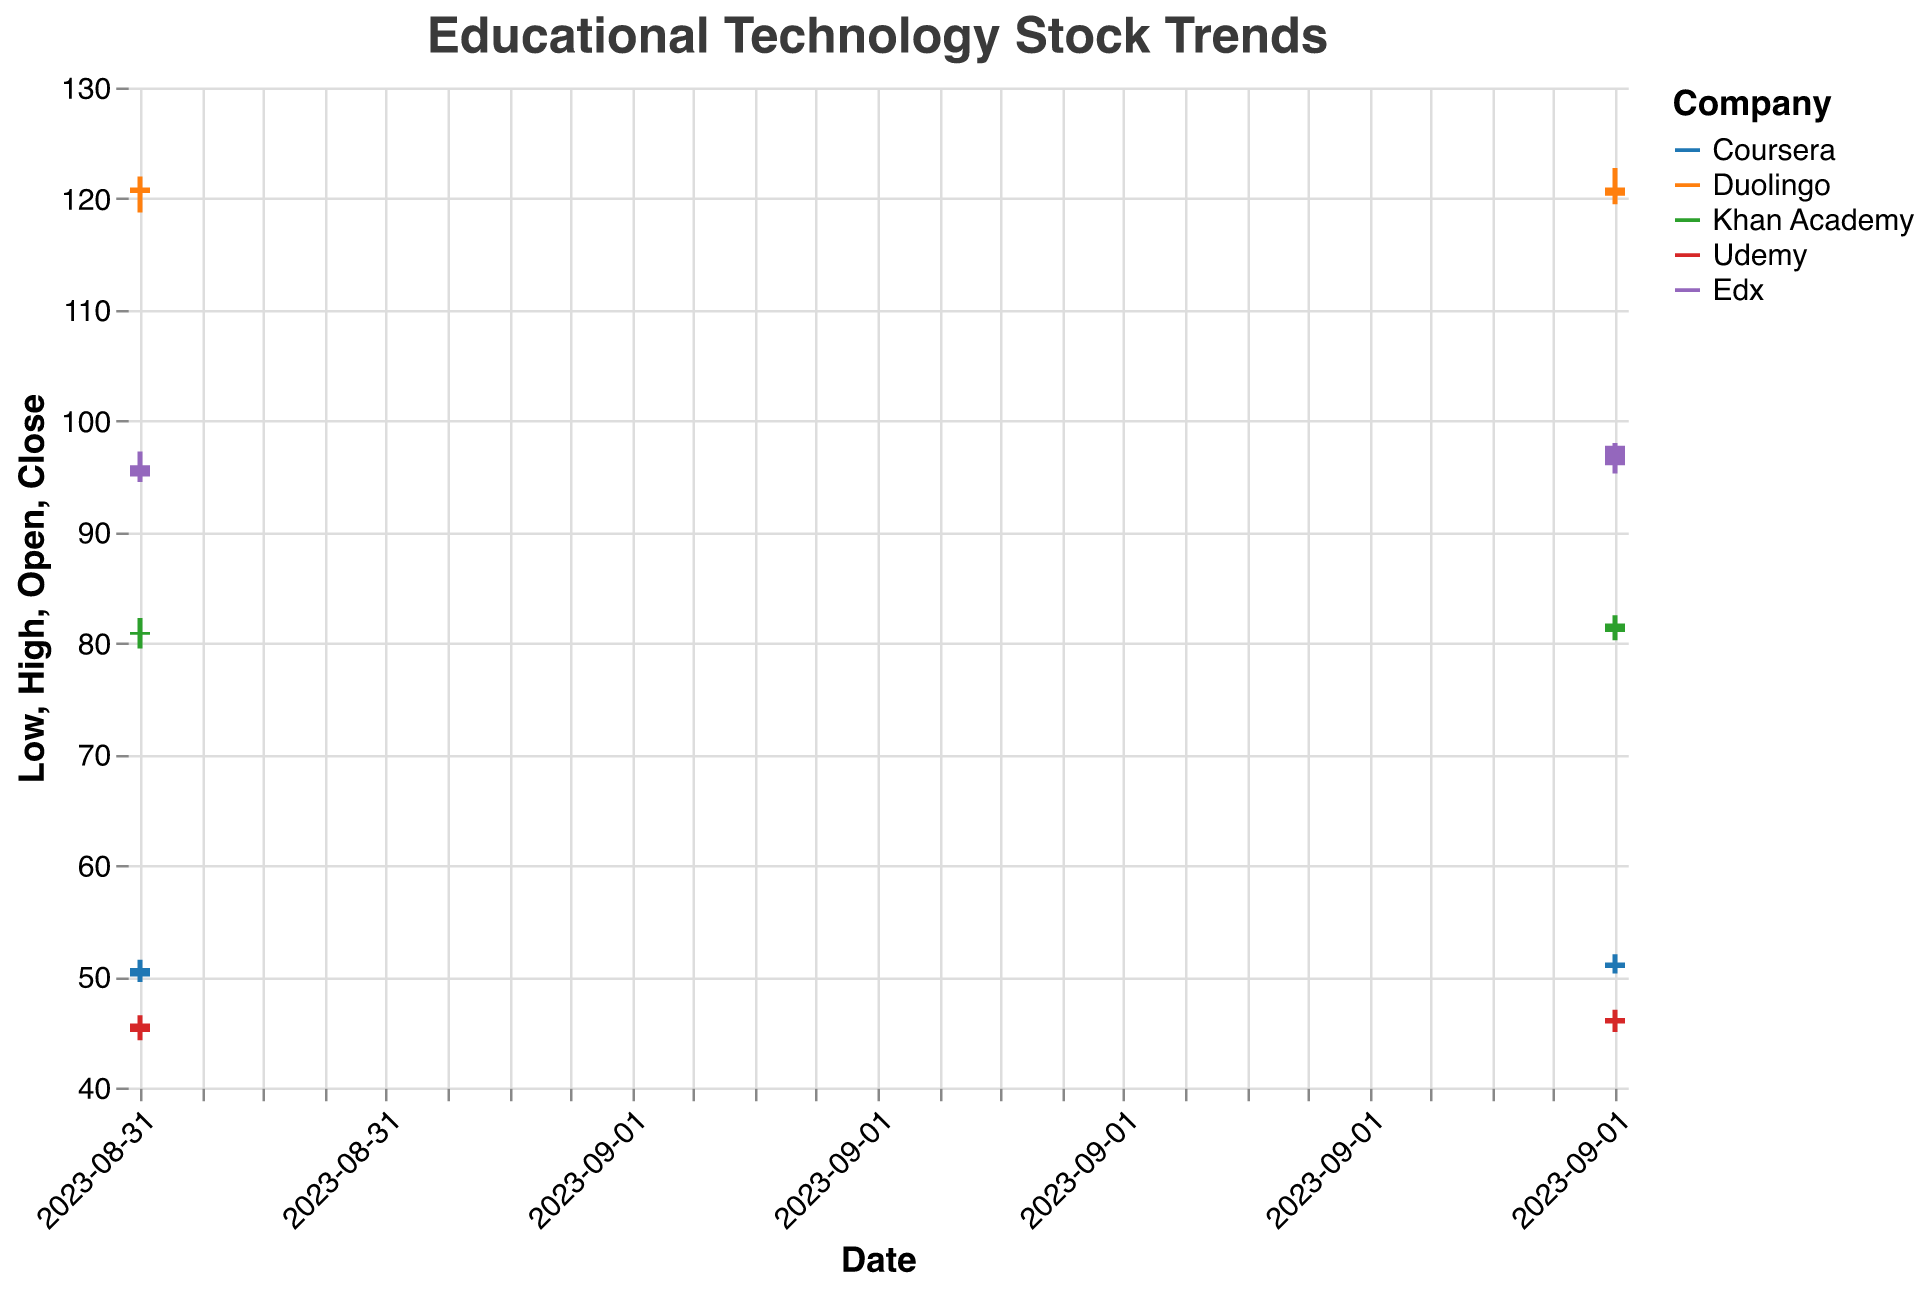What is the title of the figure? The title is written at the top of the figure and is "Educational Technology Stock Trends".
Answer: Educational Technology Stock Trends Which company had the highest closing price on 2023-09-01? Looking at the heights of the bars for 2023-09-01, Duolingo has the highest closing price at 121.00 compared to other companies.
Answer: Duolingo Between Coursera and Udemy, which company had a higher trading volume on 2023-09-02? Comparing the volume values for both companies on 2023-09-02, Coursera's trading volume is 3200000 while Udemy's is 2800000. Therefore, Coursera had a higher trading volume.
Answer: Coursera For Khan Academy, did the stock price open higher or close higher on 2023-09-02? For 2023-09-02, Khan Academy's opening price was 81.00 and its closing price was 81.75, indicating that the closing price was higher.
Answer: Close higher What is the range of stock prices (difference between high and low) for Edx on 2023-09-02? The range is calculated by subtracting the low value from the high value for Edx on 2023-09-02, which is 98.00 - 95.25 = 2.75.
Answer: 2.75 Which company's stock price increased the most from 2023-09-01 to 2023-09-02? By calculating the difference between closing prices on both dates for each company, Edx increased from 96.00 to 97.75 (1.75), which is higher than the increases for Coursera (0.50), Duolingo (decrease of 0.75), Khan Academy (0.75), and Udemy (0.50).
Answer: Edx What is the average closing price of Coursera on 2023-09-01 and 2023-09-02? The average is found by summing the closing prices for the two dates and dividing by 2: (50.75 + 51.25) / 2 = 51.00.
Answer: 51.00 How does the high price of Khan Academy on 2023-09-02 compare to the high price of Duolingo on the same date? The high price of Khan Academy on 2023-09-02 is 82.50, while Duolingo's high price on the same date is 122.75; thus, Duolingo's high price is higher.
Answer: Duolingo's high price is higher What was the closing price trend for Duolingo between 2023-09-01 and 2023-09-02? Duolingo's closing price decreased from 121.00 on 2023-09-01 to 120.25 on 2023-09-02, indicating a downward trend.
Answer: Downward trend Did any company experience a decrease in closing price from 2023-09-01 to 2023-09-02, and if so, which one(s)? Comparing the closing prices for both dates for each company, Duolingo decreased from 121.00 to 120.25.
Answer: Duolingo 